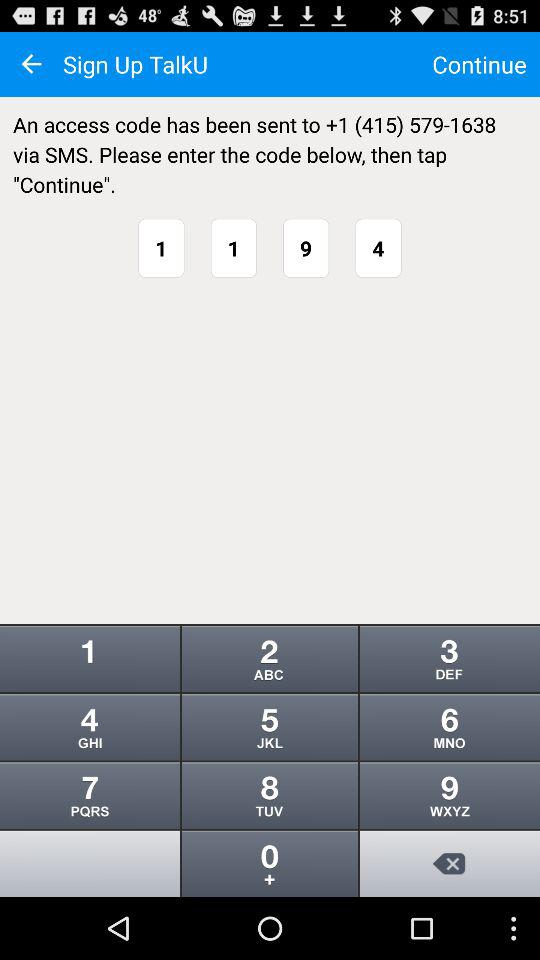How many digits are in the access code?
Answer the question using a single word or phrase. 4 